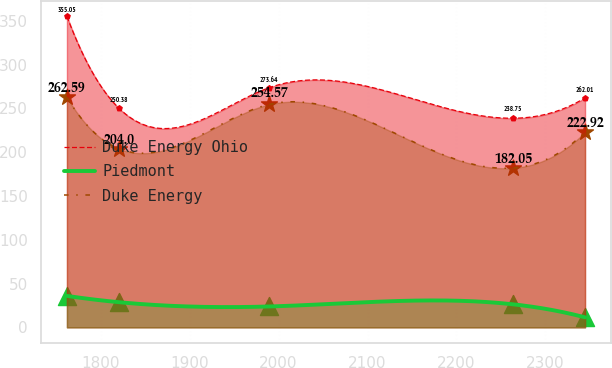Convert chart to OTSL. <chart><loc_0><loc_0><loc_500><loc_500><line_chart><ecel><fcel>Duke Energy Ohio<fcel>Piedmont<fcel>Duke Energy<nl><fcel>1762.19<fcel>355.05<fcel>35.95<fcel>262.59<nl><fcel>1820.42<fcel>250.38<fcel>28.77<fcel>204<nl><fcel>1989.53<fcel>273.64<fcel>23.87<fcel>254.57<nl><fcel>2263.63<fcel>238.75<fcel>26.32<fcel>182.05<nl><fcel>2344.51<fcel>262.01<fcel>11.47<fcel>222.92<nl></chart> 